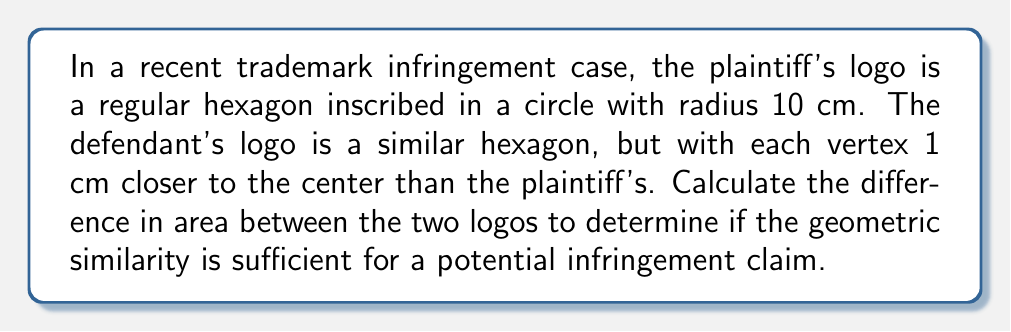What is the answer to this math problem? Let's approach this step-by-step:

1) For the plaintiff's logo:
   - The radius of the circle is 10 cm.
   - In a regular hexagon, the distance from the center to any vertex is equal to the side length.
   - Therefore, the side length of the plaintiff's hexagon is 10 cm.

2) Area of a regular hexagon is given by the formula:
   $$A = \frac{3\sqrt{3}}{2}s^2$$
   where $s$ is the side length.

3) Plaintiff's logo area:
   $$A_p = \frac{3\sqrt{3}}{2}(10)^2 = 150\sqrt{3} \approx 259.81 \text{ cm}^2$$

4) For the defendant's logo:
   - Each vertex is 1 cm closer to the center.
   - So the side length of this hexagon is 9 cm.

5) Defendant's logo area:
   $$A_d = \frac{3\sqrt{3}}{2}(9)^2 = 121.5\sqrt{3} \approx 210.45 \text{ cm}^2$$

6) The difference in area:
   $$\Delta A = A_p - A_d = 150\sqrt{3} - 121.5\sqrt{3} = 28.5\sqrt{3} \approx 49.36 \text{ cm}^2$$

This difference represents about 19% of the plaintiff's logo area, which could be significant in a trademark infringement case.
Answer: $28.5\sqrt{3} \text{ cm}^2$ or approximately 49.36 cm² 